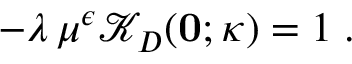Convert formula to latex. <formula><loc_0><loc_0><loc_500><loc_500>- \lambda \, \mu ^ { \epsilon } { \mathcal { K } } _ { D } ( { 0 } ; \kappa ) = 1 \, .</formula> 